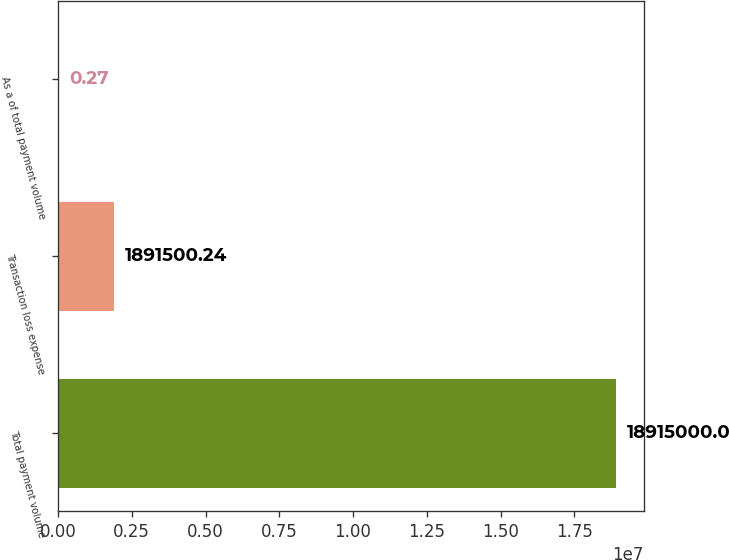Convert chart to OTSL. <chart><loc_0><loc_0><loc_500><loc_500><bar_chart><fcel>Total payment volume<fcel>Transaction loss expense<fcel>As a of total payment volume<nl><fcel>1.8915e+07<fcel>1.8915e+06<fcel>0.27<nl></chart> 